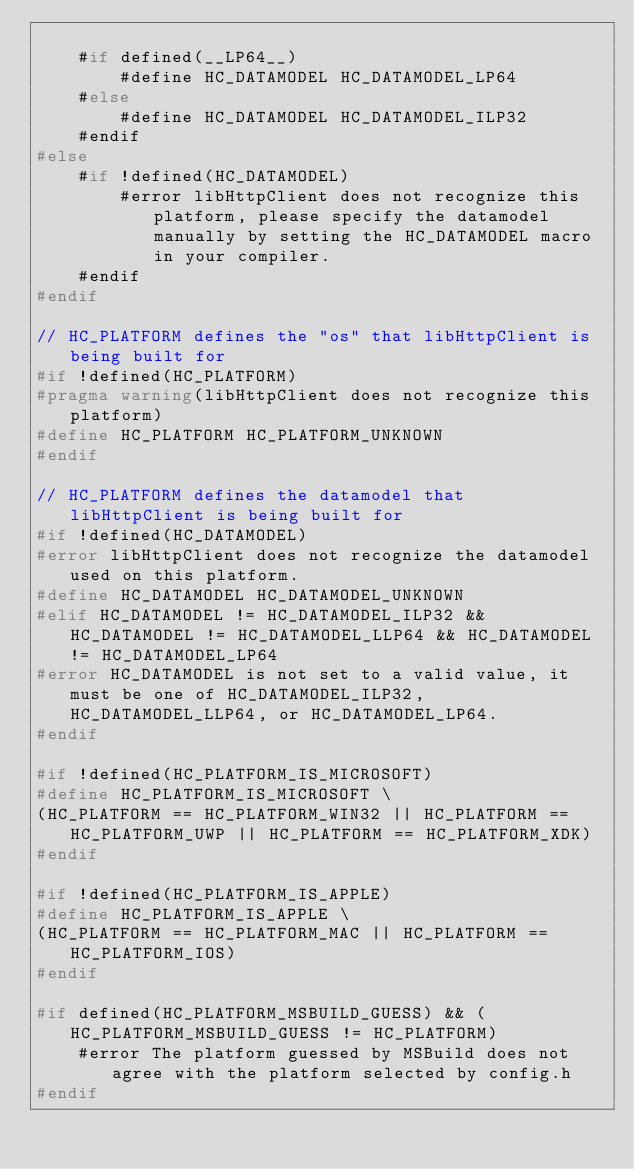Convert code to text. <code><loc_0><loc_0><loc_500><loc_500><_C_>
    #if defined(__LP64__)
        #define HC_DATAMODEL HC_DATAMODEL_LP64
    #else
        #define HC_DATAMODEL HC_DATAMODEL_ILP32
    #endif
#else
    #if !defined(HC_DATAMODEL)
        #error libHttpClient does not recognize this platform, please specify the datamodel manually by setting the HC_DATAMODEL macro in your compiler.
    #endif
#endif

// HC_PLATFORM defines the "os" that libHttpClient is being built for
#if !defined(HC_PLATFORM)
#pragma warning(libHttpClient does not recognize this platform)
#define HC_PLATFORM HC_PLATFORM_UNKNOWN
#endif

// HC_PLATFORM defines the datamodel that libHttpClient is being built for
#if !defined(HC_DATAMODEL)
#error libHttpClient does not recognize the datamodel used on this platform.
#define HC_DATAMODEL HC_DATAMODEL_UNKNOWN
#elif HC_DATAMODEL != HC_DATAMODEL_ILP32 && HC_DATAMODEL != HC_DATAMODEL_LLP64 && HC_DATAMODEL != HC_DATAMODEL_LP64
#error HC_DATAMODEL is not set to a valid value, it must be one of HC_DATAMODEL_ILP32, HC_DATAMODEL_LLP64, or HC_DATAMODEL_LP64.
#endif

#if !defined(HC_PLATFORM_IS_MICROSOFT)
#define HC_PLATFORM_IS_MICROSOFT \
(HC_PLATFORM == HC_PLATFORM_WIN32 || HC_PLATFORM == HC_PLATFORM_UWP || HC_PLATFORM == HC_PLATFORM_XDK)
#endif

#if !defined(HC_PLATFORM_IS_APPLE)
#define HC_PLATFORM_IS_APPLE \
(HC_PLATFORM == HC_PLATFORM_MAC || HC_PLATFORM == HC_PLATFORM_IOS)
#endif

#if defined(HC_PLATFORM_MSBUILD_GUESS) && (HC_PLATFORM_MSBUILD_GUESS != HC_PLATFORM)
    #error The platform guessed by MSBuild does not agree with the platform selected by config.h
#endif
</code> 